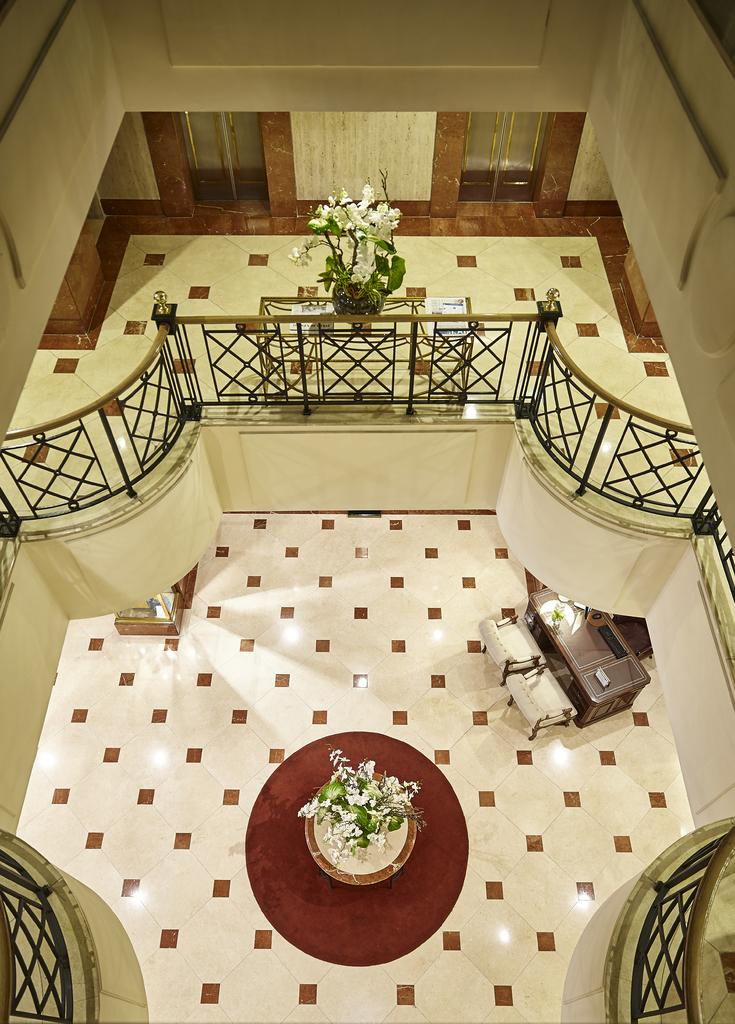What type of space is depicted in the image? The image contains a room. What is the surface on which people can stand or walk in the room? The room has a floor. What can be found in the room that contains a plant? There is a flower pot in the room. What furniture is present in the room for sitting and dining? There is a table with chairs in the room. What separates the room from the outside or other areas? There is a fence in the room. What encloses the room and provides privacy? The room has walls. How can one enter or exit the room? There are doors in the room. What type of sun is shining through the window in the room? There is no window or sun present in the image; it only shows a room with various objects and furniture. 